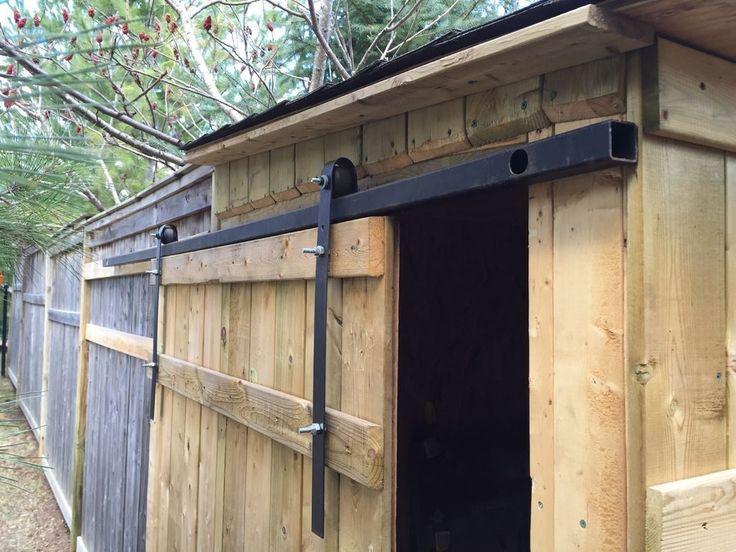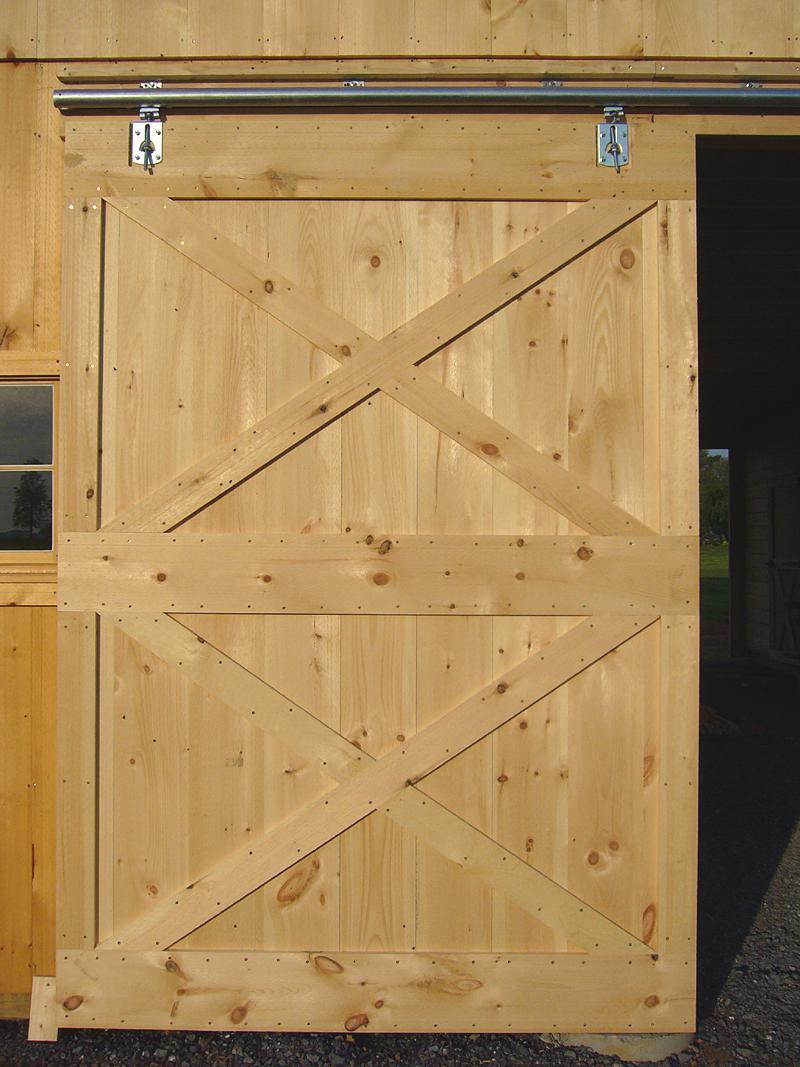The first image is the image on the left, the second image is the image on the right. For the images displayed, is the sentence "In one of the images the doors are open." factually correct? Answer yes or no. Yes. 